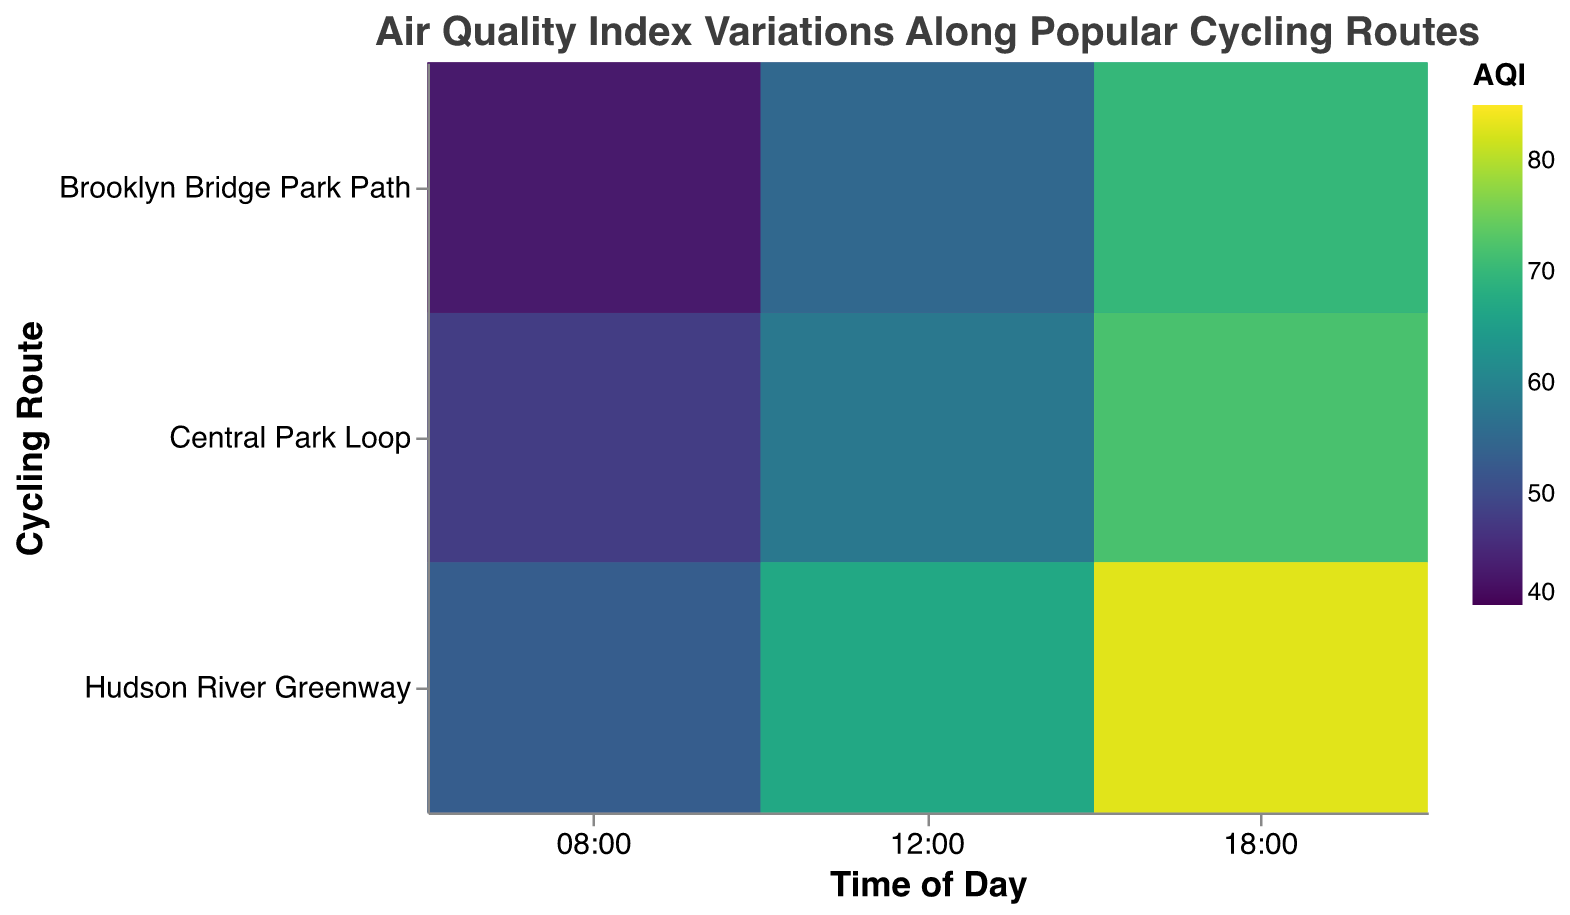When does the "Central Park Loop" have the lowest AQI at the entrance? Observing the Central Park Loop along the Time axis, we see the entrance AQI values are 45 at 08:00, 55 at 12:00, and 70 at 18:00. The lowest value is 45 at 08:00.
Answer: 08:00 Which cycling route has the highest AQI at 18:00? Check the AQI values for 18:00 across all routes. The AQI values at 18:00 are 70 for Brooklyn Bridge Park Path, 83 for Hudson River Greenway, and 75 for Central Park Loop. Hudson River Greenway has the highest AQI.
Answer: Hudson River Greenway Compare the AQI values of the "Middle" location for all routes at 12:00 and specify the highest one. Looking at 12:00 and Middle location, the AQI values are: Central Park Loop: 60, Hudson River Greenway: 68, Brooklyn Bridge Park Path: 53. The highest value is 68 for Hudson River Greenway.
Answer: 68 What is the difference in AQI between the entrance and exit of the Hudson River Greenway at 08:00? The AQI value at the entrance is 50 and at the exit is 53. The difference is 53 - 50 = 3.
Answer: 3 Which location (Entrance, Middle, or Exit) exhibits the highest AQI for the Central Park Loop at 18:00? The AQI values for Central Park Loop at 18:00 are: Entrance: 70, Middle: 75, Exit: 72. The highest value is found in the Middle.
Answer: Middle What is the average AQI for all locations of the Brooklyn Bridge Park Path at 08:00? The AQI values at 08:00 for Brooklyn Bridge Park Path are 40 (Entrance), 42 (Middle), and 43 (Exit). The average is (40+42+43)/3 = 41.67.
Answer: 41.67 Which cycling route shows the least variation in AQI from Entrance to Exit at 12:00? Calculating the variation at 12:00: 
Central Park Loop (Entrance: 55, Exit: 58, Variation: 3),
Hudson River Greenway (Entrance: 65, Exit: 67, Variation: 2),
Brooklyn Bridge Park Path (Entrance: 50, Exit: 55, Variation: 5).
The least variation is in Hudson River Greenway.
Answer: Hudson River Greenway What is the AQI value at the Middle location for the "Central Park Loop" at 08:00? The AQI value at the Middle location for Central Park Loop at 08:00 is 50.
Answer: 50 How does the AQI change from Entrance to Exit for Brooklyn Bridge Park Path at 18:00? The AQI values for Brooklyn Bridge Park Path at 18:00 are Entrance: 65, Middle: 68, and Exit: 70. The AQI increases from Entrance to Exit.
Answer: Increases What is the median AQI value for the "Hudson River Greenway" at 12:00 across all locations? The AQI values for Hudson River Greenway at 12:00 are 65 (Entrance), 68 (Middle), and 67 (Exit). The median is the middle value when sorted: 65, 67, 68 is 67.
Answer: 67 